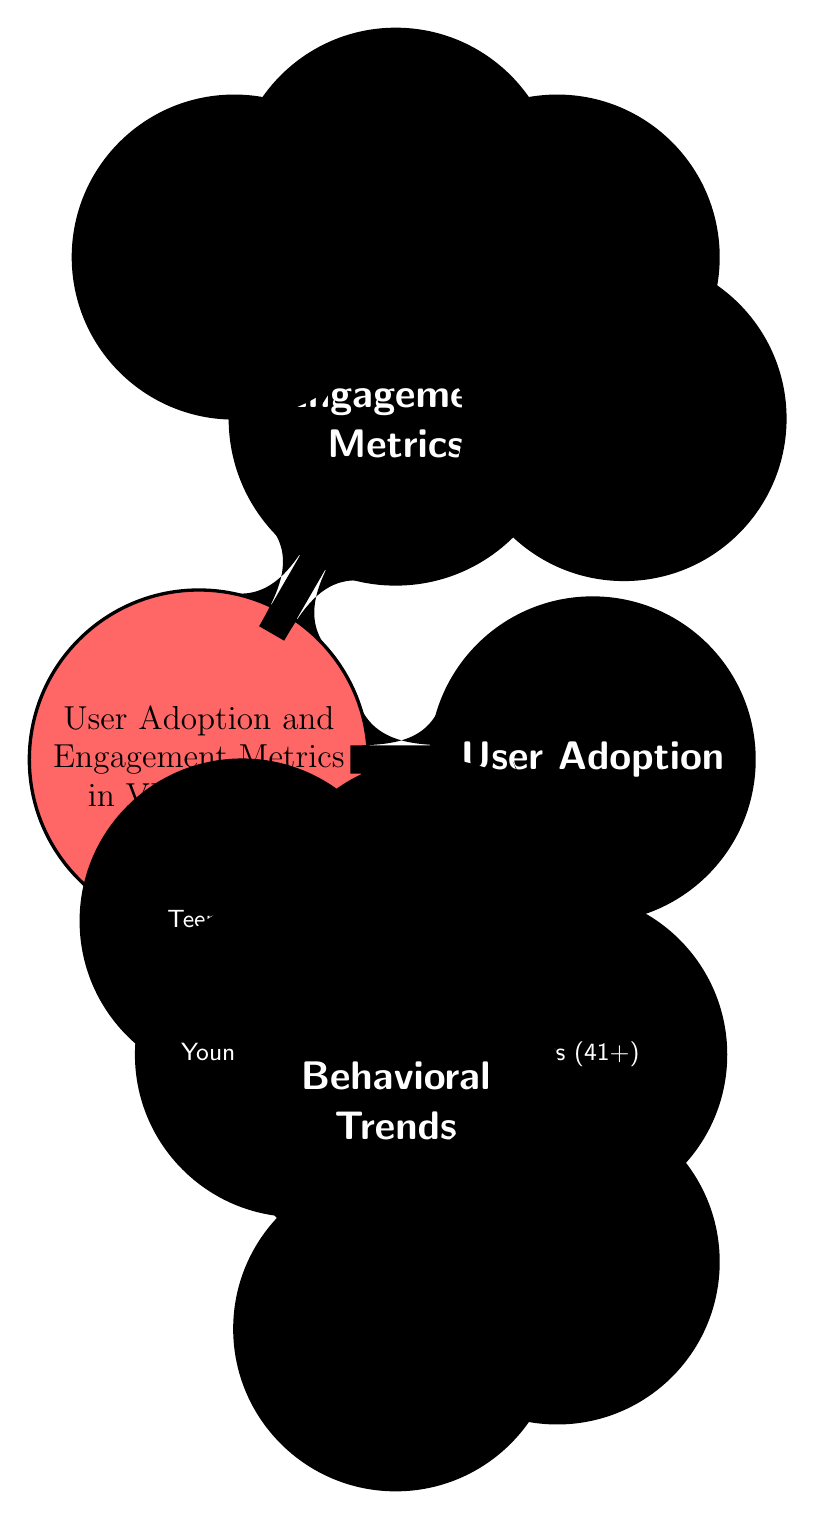What are the four age groups listed under User Adoption? The diagram shows four age groups listed as children of the "Age Groups" node. These groups are Teens (13-17), Young Adults (18-25), Adults (26-40), and Seniors (41+).
Answer: Teens (13-17), Young Adults (18-25), Adults (26-40), Seniors (41+) How many engagement metrics are specified in the diagram? The diagram has a child node called "Engagement Metrics" that branches into four specific metrics: Daily Active Users, Session Duration, Completion Rate, and Return Users. Therefore, there are a total of four engagement metrics specified.
Answer: 4 Which group is the oldest demographic on the diagram? The "Seniors (41+)" node is the last child under "Age Groups," indicating that it includes the oldest demographic in this diagram, as it encompasses individuals aged 41 and over.
Answer: Seniors (41+) What is the relationship between User Adoption and Engagement Metrics? In the visual structure of the diagram, both "User Adoption" and "Engagement Metrics" are direct children of the primary concept "User Adoption and Engagement Metrics in VR Learning." This implies they are interrelated aspects of the platform's user engagement analysis.
Answer: Interrelated Which engagement metric focuses on how often users return to the platform? The diagram identifies "Return Users" as one of the engagement metrics, which specifically measures the frequency of returning users to the virtual reality learning platform.
Answer: Return Users How many primary concepts are depicted in the diagram? The diagram has three main child nodes branching from the central node, which are "User Adoption," "Engagement Metrics," and "Behavioral Trends." This indicates there are three primary concepts presented in the diagram.
Answer: 3 Which behavioral trend is listed under Behavioral Trends? The diagram has two child nodes listed under the "Behavioral Trends" section: "Content Preference" and "Learning Outcomes." Both are indicators of user preferences and achievements in the virtual reality learning environment.
Answer: Content Preference, Learning Outcomes How does the diagram categorize the age groups? The diagram categorizes the age groups by indicating specific age ranges for each group: Teens (13-17), Young Adults (18-25), Adults (26-40), and Seniors (41+). Each range represents a distinct demographic category.
Answer: By distinct age ranges 